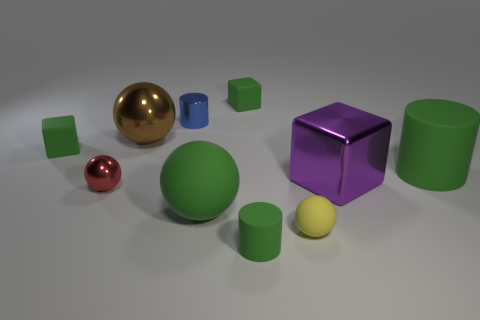Subtract 1 spheres. How many spheres are left? 3 Subtract all spheres. How many objects are left? 6 Add 2 tiny green objects. How many tiny green objects are left? 5 Add 8 gray objects. How many gray objects exist? 8 Subtract 1 purple blocks. How many objects are left? 9 Subtract all yellow objects. Subtract all small metal cylinders. How many objects are left? 8 